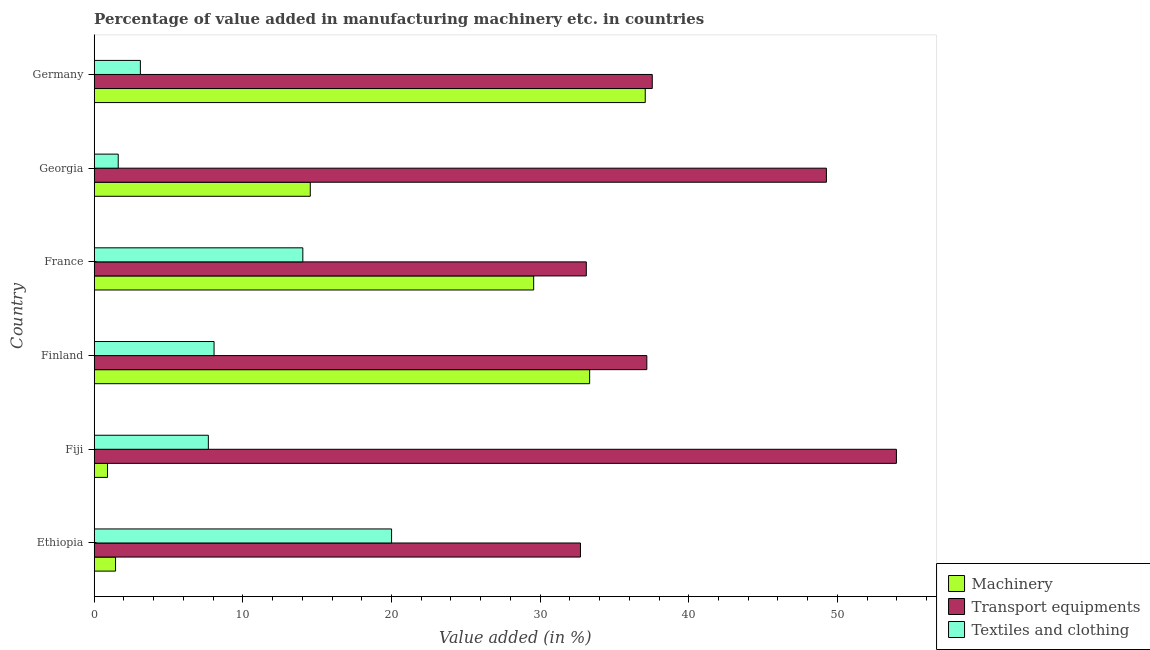How many different coloured bars are there?
Your answer should be very brief. 3. How many groups of bars are there?
Provide a short and direct response. 6. Are the number of bars on each tick of the Y-axis equal?
Your answer should be very brief. Yes. How many bars are there on the 2nd tick from the bottom?
Offer a very short reply. 3. What is the label of the 6th group of bars from the top?
Provide a short and direct response. Ethiopia. What is the value added in manufacturing machinery in Georgia?
Provide a short and direct response. 14.54. Across all countries, what is the maximum value added in manufacturing transport equipments?
Your answer should be compact. 53.97. Across all countries, what is the minimum value added in manufacturing machinery?
Offer a very short reply. 0.9. In which country was the value added in manufacturing textile and clothing maximum?
Offer a terse response. Ethiopia. In which country was the value added in manufacturing textile and clothing minimum?
Offer a very short reply. Georgia. What is the total value added in manufacturing machinery in the graph?
Keep it short and to the point. 116.84. What is the difference between the value added in manufacturing textile and clothing in Fiji and that in France?
Your answer should be very brief. -6.36. What is the difference between the value added in manufacturing textile and clothing in Fiji and the value added in manufacturing transport equipments in France?
Give a very brief answer. -25.43. What is the average value added in manufacturing machinery per country?
Give a very brief answer. 19.47. What is the difference between the value added in manufacturing transport equipments and value added in manufacturing machinery in Fiji?
Your answer should be very brief. 53.07. Is the value added in manufacturing transport equipments in Finland less than that in Georgia?
Provide a short and direct response. Yes. What is the difference between the highest and the second highest value added in manufacturing textile and clothing?
Your answer should be compact. 5.97. What is the difference between the highest and the lowest value added in manufacturing machinery?
Your answer should be compact. 36.18. In how many countries, is the value added in manufacturing textile and clothing greater than the average value added in manufacturing textile and clothing taken over all countries?
Ensure brevity in your answer.  2. Is the sum of the value added in manufacturing transport equipments in Ethiopia and Fiji greater than the maximum value added in manufacturing textile and clothing across all countries?
Keep it short and to the point. Yes. What does the 1st bar from the top in Finland represents?
Your response must be concise. Textiles and clothing. What does the 2nd bar from the bottom in Finland represents?
Give a very brief answer. Transport equipments. Is it the case that in every country, the sum of the value added in manufacturing machinery and value added in manufacturing transport equipments is greater than the value added in manufacturing textile and clothing?
Ensure brevity in your answer.  Yes. Are all the bars in the graph horizontal?
Your answer should be very brief. Yes. Are the values on the major ticks of X-axis written in scientific E-notation?
Your response must be concise. No. Does the graph contain any zero values?
Offer a terse response. No. Where does the legend appear in the graph?
Keep it short and to the point. Bottom right. How are the legend labels stacked?
Make the answer very short. Vertical. What is the title of the graph?
Your response must be concise. Percentage of value added in manufacturing machinery etc. in countries. Does "Male employers" appear as one of the legend labels in the graph?
Your answer should be very brief. No. What is the label or title of the X-axis?
Offer a terse response. Value added (in %). What is the label or title of the Y-axis?
Your response must be concise. Country. What is the Value added (in %) of Machinery in Ethiopia?
Give a very brief answer. 1.44. What is the Value added (in %) of Transport equipments in Ethiopia?
Offer a very short reply. 32.72. What is the Value added (in %) of Textiles and clothing in Ethiopia?
Give a very brief answer. 20.01. What is the Value added (in %) of Machinery in Fiji?
Provide a succinct answer. 0.9. What is the Value added (in %) in Transport equipments in Fiji?
Your answer should be very brief. 53.97. What is the Value added (in %) in Textiles and clothing in Fiji?
Keep it short and to the point. 7.68. What is the Value added (in %) of Machinery in Finland?
Offer a terse response. 33.33. What is the Value added (in %) in Transport equipments in Finland?
Your answer should be compact. 37.18. What is the Value added (in %) in Textiles and clothing in Finland?
Your answer should be very brief. 8.06. What is the Value added (in %) in Machinery in France?
Offer a very short reply. 29.57. What is the Value added (in %) of Transport equipments in France?
Your response must be concise. 33.11. What is the Value added (in %) in Textiles and clothing in France?
Your response must be concise. 14.04. What is the Value added (in %) in Machinery in Georgia?
Offer a very short reply. 14.54. What is the Value added (in %) in Transport equipments in Georgia?
Provide a short and direct response. 49.26. What is the Value added (in %) of Textiles and clothing in Georgia?
Your answer should be very brief. 1.62. What is the Value added (in %) of Machinery in Germany?
Give a very brief answer. 37.07. What is the Value added (in %) of Transport equipments in Germany?
Ensure brevity in your answer.  37.55. What is the Value added (in %) of Textiles and clothing in Germany?
Give a very brief answer. 3.11. Across all countries, what is the maximum Value added (in %) of Machinery?
Ensure brevity in your answer.  37.07. Across all countries, what is the maximum Value added (in %) of Transport equipments?
Provide a succinct answer. 53.97. Across all countries, what is the maximum Value added (in %) in Textiles and clothing?
Your answer should be very brief. 20.01. Across all countries, what is the minimum Value added (in %) in Machinery?
Your answer should be very brief. 0.9. Across all countries, what is the minimum Value added (in %) of Transport equipments?
Your answer should be very brief. 32.72. Across all countries, what is the minimum Value added (in %) of Textiles and clothing?
Keep it short and to the point. 1.62. What is the total Value added (in %) in Machinery in the graph?
Offer a very short reply. 116.84. What is the total Value added (in %) in Transport equipments in the graph?
Ensure brevity in your answer.  243.78. What is the total Value added (in %) in Textiles and clothing in the graph?
Offer a terse response. 54.51. What is the difference between the Value added (in %) in Machinery in Ethiopia and that in Fiji?
Your answer should be very brief. 0.54. What is the difference between the Value added (in %) in Transport equipments in Ethiopia and that in Fiji?
Provide a succinct answer. -21.26. What is the difference between the Value added (in %) of Textiles and clothing in Ethiopia and that in Fiji?
Keep it short and to the point. 12.33. What is the difference between the Value added (in %) of Machinery in Ethiopia and that in Finland?
Provide a succinct answer. -31.9. What is the difference between the Value added (in %) of Transport equipments in Ethiopia and that in Finland?
Provide a short and direct response. -4.46. What is the difference between the Value added (in %) of Textiles and clothing in Ethiopia and that in Finland?
Give a very brief answer. 11.94. What is the difference between the Value added (in %) of Machinery in Ethiopia and that in France?
Offer a terse response. -28.13. What is the difference between the Value added (in %) of Transport equipments in Ethiopia and that in France?
Make the answer very short. -0.39. What is the difference between the Value added (in %) of Textiles and clothing in Ethiopia and that in France?
Make the answer very short. 5.97. What is the difference between the Value added (in %) in Machinery in Ethiopia and that in Georgia?
Offer a very short reply. -13.1. What is the difference between the Value added (in %) in Transport equipments in Ethiopia and that in Georgia?
Your response must be concise. -16.54. What is the difference between the Value added (in %) of Textiles and clothing in Ethiopia and that in Georgia?
Ensure brevity in your answer.  18.39. What is the difference between the Value added (in %) in Machinery in Ethiopia and that in Germany?
Provide a succinct answer. -35.64. What is the difference between the Value added (in %) of Transport equipments in Ethiopia and that in Germany?
Your response must be concise. -4.83. What is the difference between the Value added (in %) of Textiles and clothing in Ethiopia and that in Germany?
Keep it short and to the point. 16.9. What is the difference between the Value added (in %) in Machinery in Fiji and that in Finland?
Ensure brevity in your answer.  -32.43. What is the difference between the Value added (in %) of Transport equipments in Fiji and that in Finland?
Keep it short and to the point. 16.79. What is the difference between the Value added (in %) in Textiles and clothing in Fiji and that in Finland?
Offer a very short reply. -0.38. What is the difference between the Value added (in %) in Machinery in Fiji and that in France?
Give a very brief answer. -28.67. What is the difference between the Value added (in %) of Transport equipments in Fiji and that in France?
Give a very brief answer. 20.86. What is the difference between the Value added (in %) in Textiles and clothing in Fiji and that in France?
Keep it short and to the point. -6.36. What is the difference between the Value added (in %) of Machinery in Fiji and that in Georgia?
Your answer should be compact. -13.64. What is the difference between the Value added (in %) of Transport equipments in Fiji and that in Georgia?
Keep it short and to the point. 4.71. What is the difference between the Value added (in %) in Textiles and clothing in Fiji and that in Georgia?
Provide a succinct answer. 6.06. What is the difference between the Value added (in %) in Machinery in Fiji and that in Germany?
Give a very brief answer. -36.18. What is the difference between the Value added (in %) of Transport equipments in Fiji and that in Germany?
Offer a terse response. 16.43. What is the difference between the Value added (in %) in Textiles and clothing in Fiji and that in Germany?
Keep it short and to the point. 4.57. What is the difference between the Value added (in %) in Machinery in Finland and that in France?
Make the answer very short. 3.77. What is the difference between the Value added (in %) in Transport equipments in Finland and that in France?
Provide a succinct answer. 4.07. What is the difference between the Value added (in %) of Textiles and clothing in Finland and that in France?
Your response must be concise. -5.97. What is the difference between the Value added (in %) of Machinery in Finland and that in Georgia?
Offer a terse response. 18.79. What is the difference between the Value added (in %) in Transport equipments in Finland and that in Georgia?
Make the answer very short. -12.08. What is the difference between the Value added (in %) of Textiles and clothing in Finland and that in Georgia?
Make the answer very short. 6.45. What is the difference between the Value added (in %) of Machinery in Finland and that in Germany?
Ensure brevity in your answer.  -3.74. What is the difference between the Value added (in %) in Transport equipments in Finland and that in Germany?
Your answer should be very brief. -0.37. What is the difference between the Value added (in %) in Textiles and clothing in Finland and that in Germany?
Offer a terse response. 4.96. What is the difference between the Value added (in %) in Machinery in France and that in Georgia?
Offer a terse response. 15.03. What is the difference between the Value added (in %) of Transport equipments in France and that in Georgia?
Give a very brief answer. -16.15. What is the difference between the Value added (in %) in Textiles and clothing in France and that in Georgia?
Provide a succinct answer. 12.42. What is the difference between the Value added (in %) of Machinery in France and that in Germany?
Offer a terse response. -7.51. What is the difference between the Value added (in %) in Transport equipments in France and that in Germany?
Provide a succinct answer. -4.44. What is the difference between the Value added (in %) in Textiles and clothing in France and that in Germany?
Your answer should be very brief. 10.93. What is the difference between the Value added (in %) in Machinery in Georgia and that in Germany?
Give a very brief answer. -22.54. What is the difference between the Value added (in %) of Transport equipments in Georgia and that in Germany?
Your response must be concise. 11.72. What is the difference between the Value added (in %) of Textiles and clothing in Georgia and that in Germany?
Provide a succinct answer. -1.49. What is the difference between the Value added (in %) of Machinery in Ethiopia and the Value added (in %) of Transport equipments in Fiji?
Your answer should be very brief. -52.54. What is the difference between the Value added (in %) in Machinery in Ethiopia and the Value added (in %) in Textiles and clothing in Fiji?
Your response must be concise. -6.24. What is the difference between the Value added (in %) in Transport equipments in Ethiopia and the Value added (in %) in Textiles and clothing in Fiji?
Your answer should be compact. 25.04. What is the difference between the Value added (in %) of Machinery in Ethiopia and the Value added (in %) of Transport equipments in Finland?
Offer a terse response. -35.74. What is the difference between the Value added (in %) in Machinery in Ethiopia and the Value added (in %) in Textiles and clothing in Finland?
Keep it short and to the point. -6.63. What is the difference between the Value added (in %) in Transport equipments in Ethiopia and the Value added (in %) in Textiles and clothing in Finland?
Ensure brevity in your answer.  24.65. What is the difference between the Value added (in %) in Machinery in Ethiopia and the Value added (in %) in Transport equipments in France?
Keep it short and to the point. -31.67. What is the difference between the Value added (in %) in Machinery in Ethiopia and the Value added (in %) in Textiles and clothing in France?
Ensure brevity in your answer.  -12.6. What is the difference between the Value added (in %) in Transport equipments in Ethiopia and the Value added (in %) in Textiles and clothing in France?
Your answer should be compact. 18.68. What is the difference between the Value added (in %) in Machinery in Ethiopia and the Value added (in %) in Transport equipments in Georgia?
Make the answer very short. -47.82. What is the difference between the Value added (in %) of Machinery in Ethiopia and the Value added (in %) of Textiles and clothing in Georgia?
Offer a terse response. -0.18. What is the difference between the Value added (in %) in Transport equipments in Ethiopia and the Value added (in %) in Textiles and clothing in Georgia?
Give a very brief answer. 31.1. What is the difference between the Value added (in %) of Machinery in Ethiopia and the Value added (in %) of Transport equipments in Germany?
Your answer should be compact. -36.11. What is the difference between the Value added (in %) of Machinery in Ethiopia and the Value added (in %) of Textiles and clothing in Germany?
Offer a very short reply. -1.67. What is the difference between the Value added (in %) in Transport equipments in Ethiopia and the Value added (in %) in Textiles and clothing in Germany?
Provide a succinct answer. 29.61. What is the difference between the Value added (in %) in Machinery in Fiji and the Value added (in %) in Transport equipments in Finland?
Keep it short and to the point. -36.28. What is the difference between the Value added (in %) of Machinery in Fiji and the Value added (in %) of Textiles and clothing in Finland?
Make the answer very short. -7.17. What is the difference between the Value added (in %) of Transport equipments in Fiji and the Value added (in %) of Textiles and clothing in Finland?
Provide a short and direct response. 45.91. What is the difference between the Value added (in %) in Machinery in Fiji and the Value added (in %) in Transport equipments in France?
Your answer should be compact. -32.21. What is the difference between the Value added (in %) in Machinery in Fiji and the Value added (in %) in Textiles and clothing in France?
Provide a short and direct response. -13.14. What is the difference between the Value added (in %) in Transport equipments in Fiji and the Value added (in %) in Textiles and clothing in France?
Provide a succinct answer. 39.94. What is the difference between the Value added (in %) of Machinery in Fiji and the Value added (in %) of Transport equipments in Georgia?
Offer a terse response. -48.36. What is the difference between the Value added (in %) of Machinery in Fiji and the Value added (in %) of Textiles and clothing in Georgia?
Keep it short and to the point. -0.72. What is the difference between the Value added (in %) in Transport equipments in Fiji and the Value added (in %) in Textiles and clothing in Georgia?
Keep it short and to the point. 52.36. What is the difference between the Value added (in %) in Machinery in Fiji and the Value added (in %) in Transport equipments in Germany?
Offer a very short reply. -36.65. What is the difference between the Value added (in %) of Machinery in Fiji and the Value added (in %) of Textiles and clothing in Germany?
Your answer should be compact. -2.21. What is the difference between the Value added (in %) in Transport equipments in Fiji and the Value added (in %) in Textiles and clothing in Germany?
Offer a terse response. 50.86. What is the difference between the Value added (in %) of Machinery in Finland and the Value added (in %) of Transport equipments in France?
Provide a succinct answer. 0.22. What is the difference between the Value added (in %) in Machinery in Finland and the Value added (in %) in Textiles and clothing in France?
Make the answer very short. 19.3. What is the difference between the Value added (in %) in Transport equipments in Finland and the Value added (in %) in Textiles and clothing in France?
Ensure brevity in your answer.  23.14. What is the difference between the Value added (in %) of Machinery in Finland and the Value added (in %) of Transport equipments in Georgia?
Your response must be concise. -15.93. What is the difference between the Value added (in %) of Machinery in Finland and the Value added (in %) of Textiles and clothing in Georgia?
Your response must be concise. 31.72. What is the difference between the Value added (in %) of Transport equipments in Finland and the Value added (in %) of Textiles and clothing in Georgia?
Make the answer very short. 35.56. What is the difference between the Value added (in %) in Machinery in Finland and the Value added (in %) in Transport equipments in Germany?
Keep it short and to the point. -4.21. What is the difference between the Value added (in %) of Machinery in Finland and the Value added (in %) of Textiles and clothing in Germany?
Provide a short and direct response. 30.22. What is the difference between the Value added (in %) of Transport equipments in Finland and the Value added (in %) of Textiles and clothing in Germany?
Keep it short and to the point. 34.07. What is the difference between the Value added (in %) of Machinery in France and the Value added (in %) of Transport equipments in Georgia?
Give a very brief answer. -19.69. What is the difference between the Value added (in %) of Machinery in France and the Value added (in %) of Textiles and clothing in Georgia?
Your response must be concise. 27.95. What is the difference between the Value added (in %) in Transport equipments in France and the Value added (in %) in Textiles and clothing in Georgia?
Offer a very short reply. 31.49. What is the difference between the Value added (in %) in Machinery in France and the Value added (in %) in Transport equipments in Germany?
Your answer should be very brief. -7.98. What is the difference between the Value added (in %) of Machinery in France and the Value added (in %) of Textiles and clothing in Germany?
Give a very brief answer. 26.46. What is the difference between the Value added (in %) in Transport equipments in France and the Value added (in %) in Textiles and clothing in Germany?
Offer a very short reply. 30. What is the difference between the Value added (in %) of Machinery in Georgia and the Value added (in %) of Transport equipments in Germany?
Offer a very short reply. -23.01. What is the difference between the Value added (in %) of Machinery in Georgia and the Value added (in %) of Textiles and clothing in Germany?
Your answer should be compact. 11.43. What is the difference between the Value added (in %) of Transport equipments in Georgia and the Value added (in %) of Textiles and clothing in Germany?
Ensure brevity in your answer.  46.15. What is the average Value added (in %) in Machinery per country?
Make the answer very short. 19.47. What is the average Value added (in %) of Transport equipments per country?
Give a very brief answer. 40.63. What is the average Value added (in %) in Textiles and clothing per country?
Make the answer very short. 9.08. What is the difference between the Value added (in %) of Machinery and Value added (in %) of Transport equipments in Ethiopia?
Provide a succinct answer. -31.28. What is the difference between the Value added (in %) of Machinery and Value added (in %) of Textiles and clothing in Ethiopia?
Keep it short and to the point. -18.57. What is the difference between the Value added (in %) in Transport equipments and Value added (in %) in Textiles and clothing in Ethiopia?
Make the answer very short. 12.71. What is the difference between the Value added (in %) in Machinery and Value added (in %) in Transport equipments in Fiji?
Your response must be concise. -53.07. What is the difference between the Value added (in %) in Machinery and Value added (in %) in Textiles and clothing in Fiji?
Your answer should be very brief. -6.78. What is the difference between the Value added (in %) in Transport equipments and Value added (in %) in Textiles and clothing in Fiji?
Offer a terse response. 46.29. What is the difference between the Value added (in %) in Machinery and Value added (in %) in Transport equipments in Finland?
Make the answer very short. -3.85. What is the difference between the Value added (in %) of Machinery and Value added (in %) of Textiles and clothing in Finland?
Ensure brevity in your answer.  25.27. What is the difference between the Value added (in %) of Transport equipments and Value added (in %) of Textiles and clothing in Finland?
Offer a very short reply. 29.12. What is the difference between the Value added (in %) in Machinery and Value added (in %) in Transport equipments in France?
Your answer should be compact. -3.54. What is the difference between the Value added (in %) in Machinery and Value added (in %) in Textiles and clothing in France?
Offer a very short reply. 15.53. What is the difference between the Value added (in %) in Transport equipments and Value added (in %) in Textiles and clothing in France?
Your answer should be very brief. 19.07. What is the difference between the Value added (in %) of Machinery and Value added (in %) of Transport equipments in Georgia?
Offer a terse response. -34.72. What is the difference between the Value added (in %) of Machinery and Value added (in %) of Textiles and clothing in Georgia?
Give a very brief answer. 12.92. What is the difference between the Value added (in %) of Transport equipments and Value added (in %) of Textiles and clothing in Georgia?
Keep it short and to the point. 47.64. What is the difference between the Value added (in %) of Machinery and Value added (in %) of Transport equipments in Germany?
Offer a terse response. -0.47. What is the difference between the Value added (in %) in Machinery and Value added (in %) in Textiles and clothing in Germany?
Provide a succinct answer. 33.97. What is the difference between the Value added (in %) in Transport equipments and Value added (in %) in Textiles and clothing in Germany?
Make the answer very short. 34.44. What is the ratio of the Value added (in %) in Machinery in Ethiopia to that in Fiji?
Your answer should be compact. 1.6. What is the ratio of the Value added (in %) of Transport equipments in Ethiopia to that in Fiji?
Keep it short and to the point. 0.61. What is the ratio of the Value added (in %) in Textiles and clothing in Ethiopia to that in Fiji?
Offer a very short reply. 2.61. What is the ratio of the Value added (in %) of Machinery in Ethiopia to that in Finland?
Provide a short and direct response. 0.04. What is the ratio of the Value added (in %) in Textiles and clothing in Ethiopia to that in Finland?
Offer a terse response. 2.48. What is the ratio of the Value added (in %) of Machinery in Ethiopia to that in France?
Provide a succinct answer. 0.05. What is the ratio of the Value added (in %) of Transport equipments in Ethiopia to that in France?
Ensure brevity in your answer.  0.99. What is the ratio of the Value added (in %) of Textiles and clothing in Ethiopia to that in France?
Provide a succinct answer. 1.43. What is the ratio of the Value added (in %) of Machinery in Ethiopia to that in Georgia?
Your answer should be very brief. 0.1. What is the ratio of the Value added (in %) in Transport equipments in Ethiopia to that in Georgia?
Your answer should be compact. 0.66. What is the ratio of the Value added (in %) in Textiles and clothing in Ethiopia to that in Georgia?
Keep it short and to the point. 12.38. What is the ratio of the Value added (in %) of Machinery in Ethiopia to that in Germany?
Your answer should be very brief. 0.04. What is the ratio of the Value added (in %) in Transport equipments in Ethiopia to that in Germany?
Offer a very short reply. 0.87. What is the ratio of the Value added (in %) of Textiles and clothing in Ethiopia to that in Germany?
Keep it short and to the point. 6.44. What is the ratio of the Value added (in %) in Machinery in Fiji to that in Finland?
Provide a succinct answer. 0.03. What is the ratio of the Value added (in %) of Transport equipments in Fiji to that in Finland?
Give a very brief answer. 1.45. What is the ratio of the Value added (in %) in Textiles and clothing in Fiji to that in Finland?
Provide a short and direct response. 0.95. What is the ratio of the Value added (in %) in Machinery in Fiji to that in France?
Your answer should be compact. 0.03. What is the ratio of the Value added (in %) in Transport equipments in Fiji to that in France?
Make the answer very short. 1.63. What is the ratio of the Value added (in %) in Textiles and clothing in Fiji to that in France?
Keep it short and to the point. 0.55. What is the ratio of the Value added (in %) in Machinery in Fiji to that in Georgia?
Your response must be concise. 0.06. What is the ratio of the Value added (in %) in Transport equipments in Fiji to that in Georgia?
Your response must be concise. 1.1. What is the ratio of the Value added (in %) in Textiles and clothing in Fiji to that in Georgia?
Offer a very short reply. 4.75. What is the ratio of the Value added (in %) in Machinery in Fiji to that in Germany?
Give a very brief answer. 0.02. What is the ratio of the Value added (in %) of Transport equipments in Fiji to that in Germany?
Your answer should be compact. 1.44. What is the ratio of the Value added (in %) of Textiles and clothing in Fiji to that in Germany?
Provide a short and direct response. 2.47. What is the ratio of the Value added (in %) in Machinery in Finland to that in France?
Offer a very short reply. 1.13. What is the ratio of the Value added (in %) of Transport equipments in Finland to that in France?
Provide a succinct answer. 1.12. What is the ratio of the Value added (in %) of Textiles and clothing in Finland to that in France?
Provide a short and direct response. 0.57. What is the ratio of the Value added (in %) of Machinery in Finland to that in Georgia?
Offer a very short reply. 2.29. What is the ratio of the Value added (in %) of Transport equipments in Finland to that in Georgia?
Your answer should be very brief. 0.75. What is the ratio of the Value added (in %) in Textiles and clothing in Finland to that in Georgia?
Give a very brief answer. 4.99. What is the ratio of the Value added (in %) of Machinery in Finland to that in Germany?
Your answer should be very brief. 0.9. What is the ratio of the Value added (in %) of Transport equipments in Finland to that in Germany?
Give a very brief answer. 0.99. What is the ratio of the Value added (in %) in Textiles and clothing in Finland to that in Germany?
Provide a succinct answer. 2.6. What is the ratio of the Value added (in %) in Machinery in France to that in Georgia?
Your response must be concise. 2.03. What is the ratio of the Value added (in %) in Transport equipments in France to that in Georgia?
Offer a terse response. 0.67. What is the ratio of the Value added (in %) in Textiles and clothing in France to that in Georgia?
Provide a succinct answer. 8.69. What is the ratio of the Value added (in %) in Machinery in France to that in Germany?
Keep it short and to the point. 0.8. What is the ratio of the Value added (in %) of Transport equipments in France to that in Germany?
Keep it short and to the point. 0.88. What is the ratio of the Value added (in %) in Textiles and clothing in France to that in Germany?
Offer a very short reply. 4.52. What is the ratio of the Value added (in %) of Machinery in Georgia to that in Germany?
Offer a terse response. 0.39. What is the ratio of the Value added (in %) of Transport equipments in Georgia to that in Germany?
Keep it short and to the point. 1.31. What is the ratio of the Value added (in %) in Textiles and clothing in Georgia to that in Germany?
Your answer should be very brief. 0.52. What is the difference between the highest and the second highest Value added (in %) of Machinery?
Your response must be concise. 3.74. What is the difference between the highest and the second highest Value added (in %) in Transport equipments?
Your answer should be compact. 4.71. What is the difference between the highest and the second highest Value added (in %) of Textiles and clothing?
Keep it short and to the point. 5.97. What is the difference between the highest and the lowest Value added (in %) of Machinery?
Provide a short and direct response. 36.18. What is the difference between the highest and the lowest Value added (in %) of Transport equipments?
Make the answer very short. 21.26. What is the difference between the highest and the lowest Value added (in %) of Textiles and clothing?
Your answer should be very brief. 18.39. 